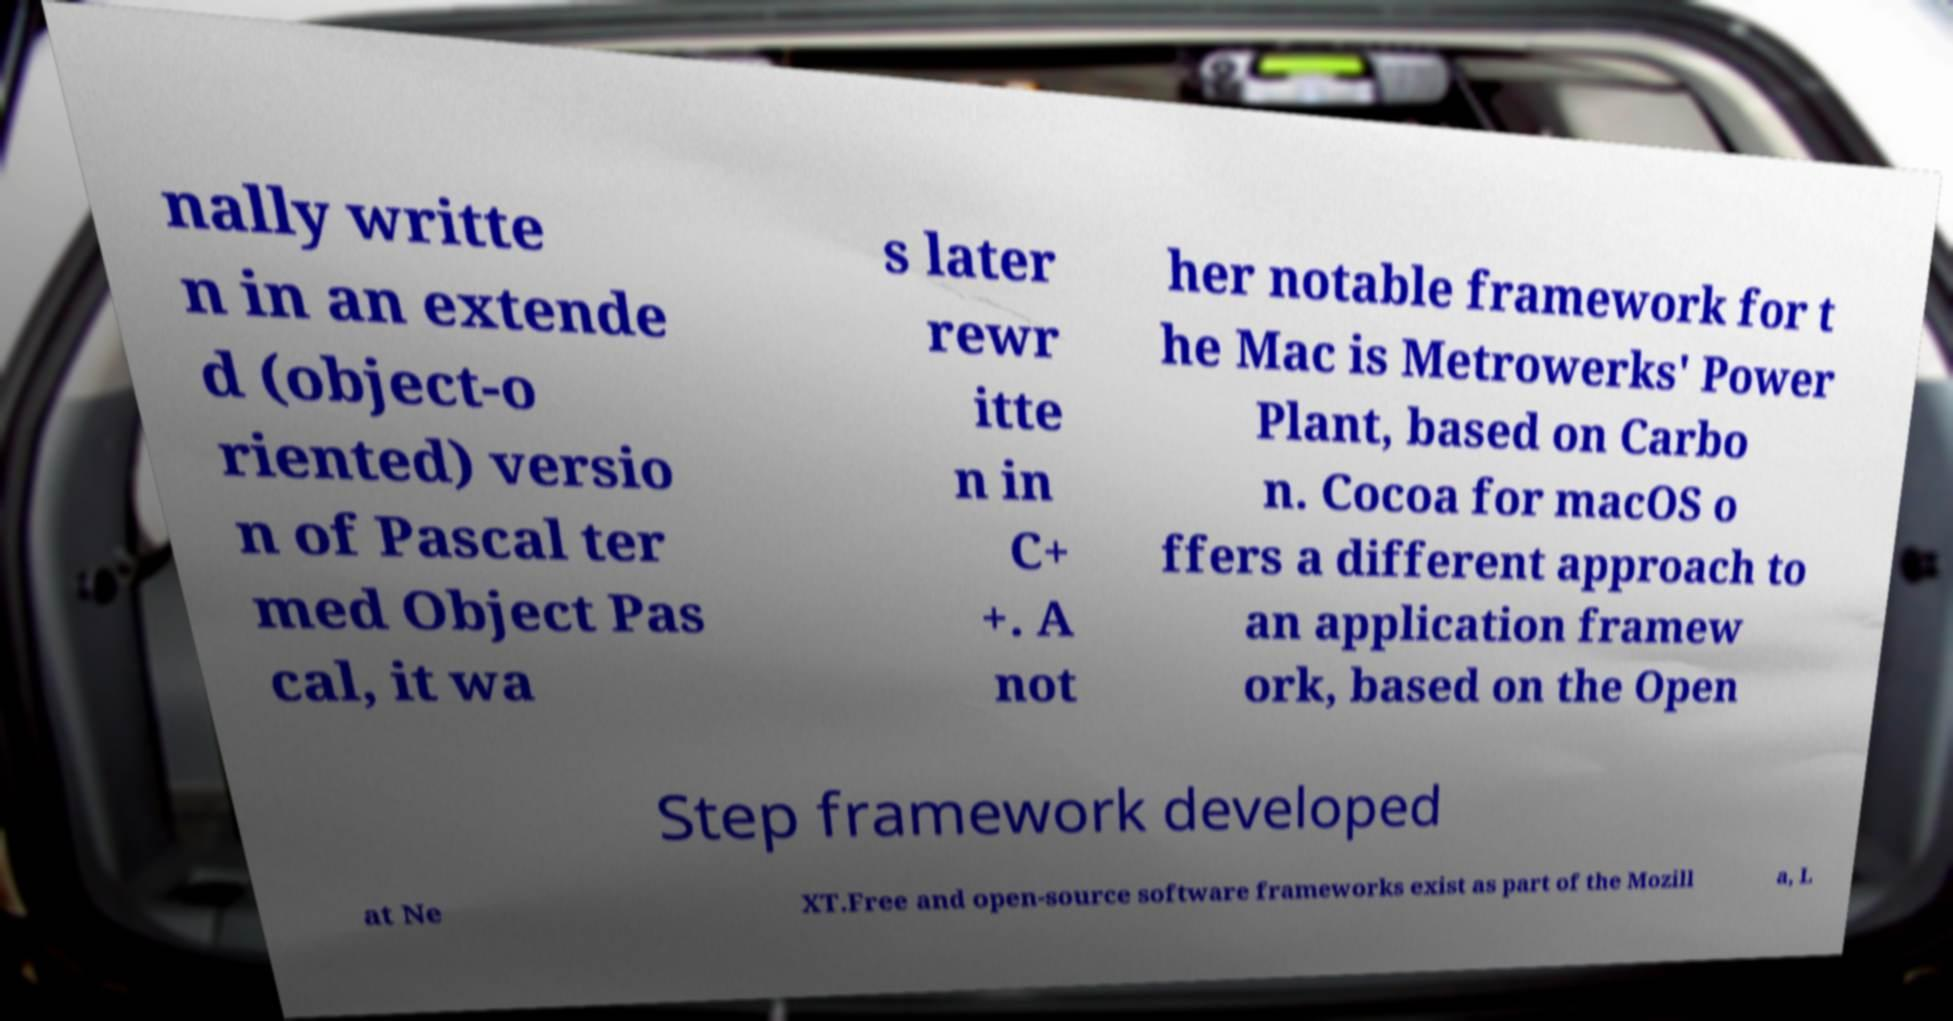Please identify and transcribe the text found in this image. nally writte n in an extende d (object-o riented) versio n of Pascal ter med Object Pas cal, it wa s later rewr itte n in C+ +. A not her notable framework for t he Mac is Metrowerks' Power Plant, based on Carbo n. Cocoa for macOS o ffers a different approach to an application framew ork, based on the Open Step framework developed at Ne XT.Free and open-source software frameworks exist as part of the Mozill a, L 